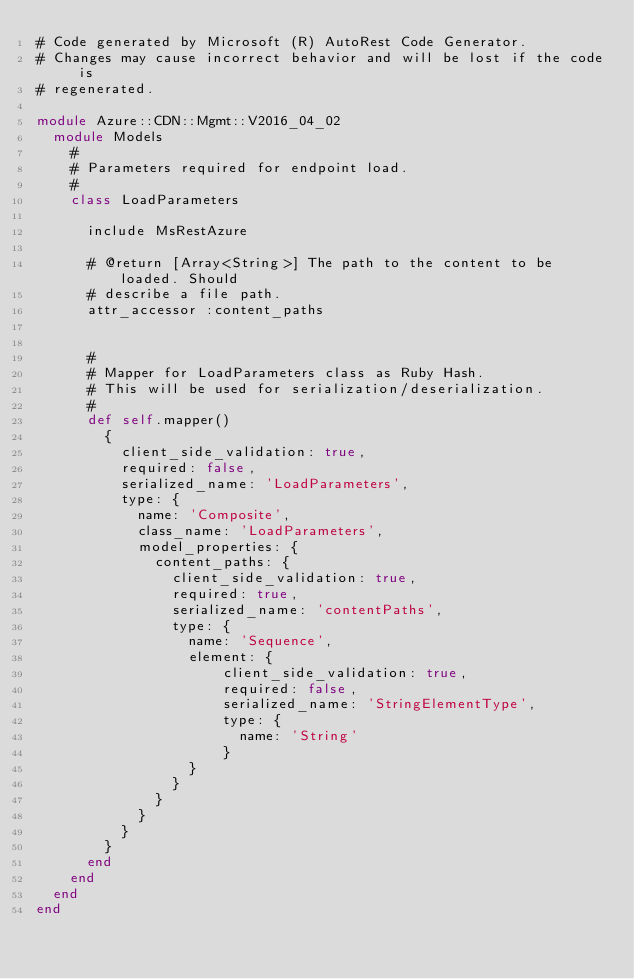Convert code to text. <code><loc_0><loc_0><loc_500><loc_500><_Ruby_># Code generated by Microsoft (R) AutoRest Code Generator.
# Changes may cause incorrect behavior and will be lost if the code is
# regenerated.

module Azure::CDN::Mgmt::V2016_04_02
  module Models
    #
    # Parameters required for endpoint load.
    #
    class LoadParameters

      include MsRestAzure

      # @return [Array<String>] The path to the content to be loaded. Should
      # describe a file path.
      attr_accessor :content_paths


      #
      # Mapper for LoadParameters class as Ruby Hash.
      # This will be used for serialization/deserialization.
      #
      def self.mapper()
        {
          client_side_validation: true,
          required: false,
          serialized_name: 'LoadParameters',
          type: {
            name: 'Composite',
            class_name: 'LoadParameters',
            model_properties: {
              content_paths: {
                client_side_validation: true,
                required: true,
                serialized_name: 'contentPaths',
                type: {
                  name: 'Sequence',
                  element: {
                      client_side_validation: true,
                      required: false,
                      serialized_name: 'StringElementType',
                      type: {
                        name: 'String'
                      }
                  }
                }
              }
            }
          }
        }
      end
    end
  end
end
</code> 